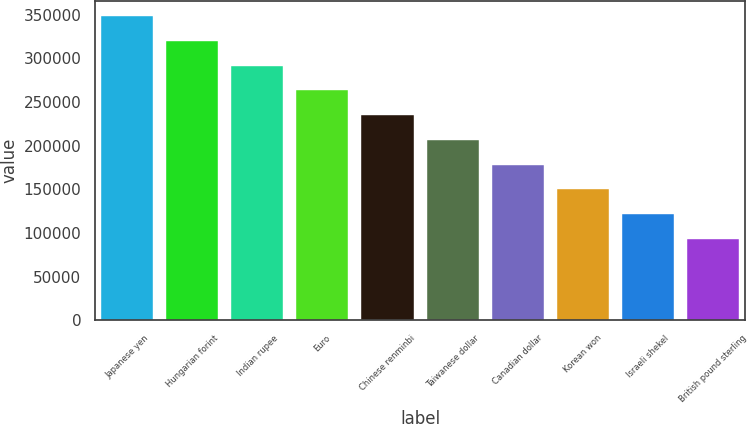Convert chart. <chart><loc_0><loc_0><loc_500><loc_500><bar_chart><fcel>Japanese yen<fcel>Hungarian forint<fcel>Indian rupee<fcel>Euro<fcel>Chinese renminbi<fcel>Taiwanese dollar<fcel>Canadian dollar<fcel>Korean won<fcel>Israeli shekel<fcel>British pound sterling<nl><fcel>348099<fcel>319797<fcel>291495<fcel>263193<fcel>234891<fcel>206588<fcel>178286<fcel>149984<fcel>121682<fcel>93379.6<nl></chart> 